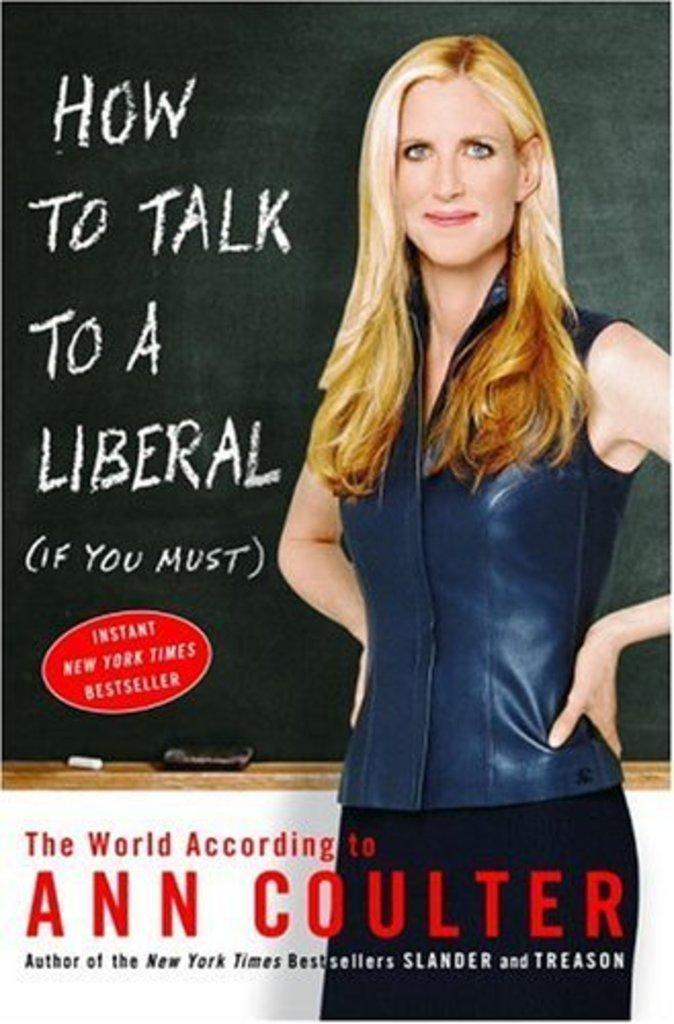Could you give a brief overview of what you see in this image? In the center of the image we can see a poster. On the poster, we can see one person, one board, some text and some objects. 